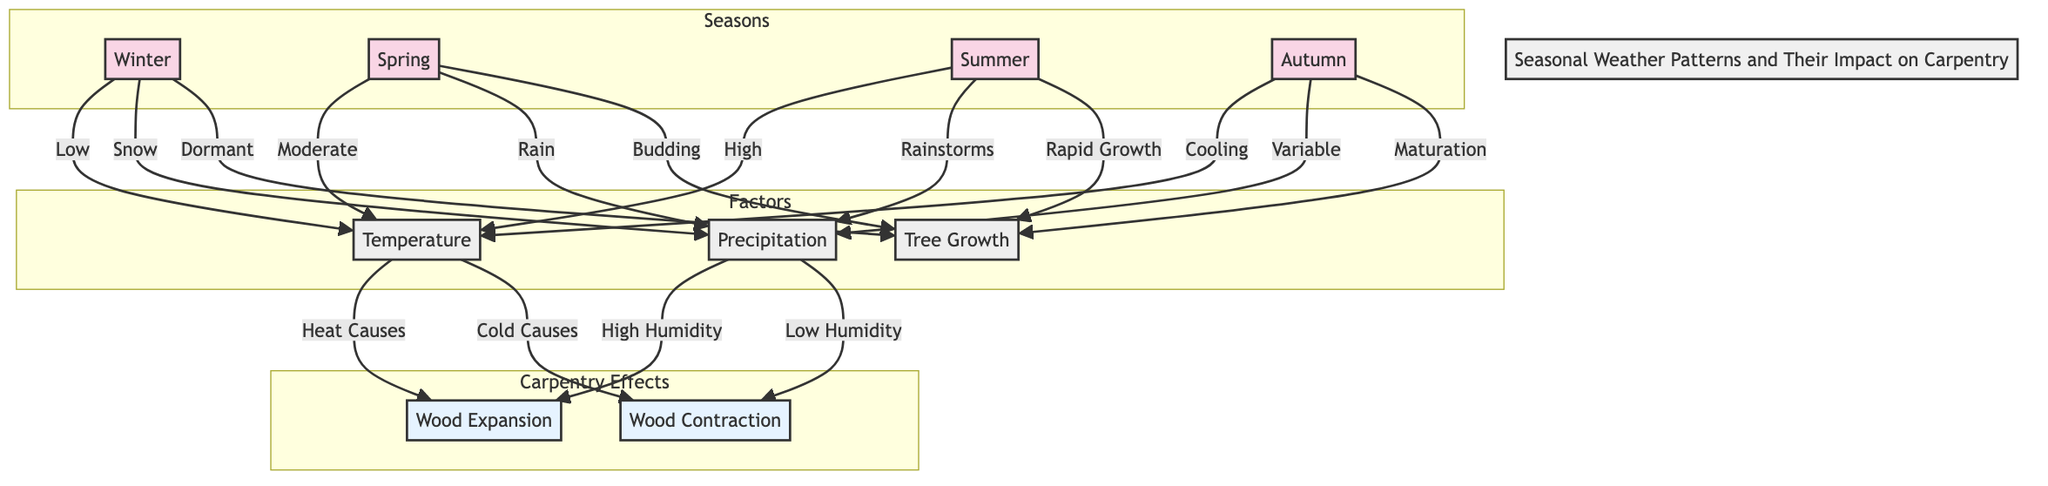What season is associated with low temperatures? The diagram shows that the winter season is linked to low temperatures, as indicated by the directed arrow relationship from Winter to Temperature with the label "Low."
Answer: Winter Which season is connected to rapid tree growth? The diagram specifies that rapid tree growth occurs during the summer season, indicated by the directed arrow from Summer to Tree Growth with the label "Rapid Growth."
Answer: Summer How many seasons are represented in the diagram? The diagram categorizes four distinct seasons: Winter, Spring, Summer, and Autumn. Thus, the count of seasons represented is four.
Answer: Four What effect does high humidity have on wood? According to the diagram, high humidity, represented by the precipitation node, causes wood to expand, as indicated by the directed arrow from Precipitation to Wood Expansion with the label "High Humidity."
Answer: Wood Expansion What is the relationship between temperature and wood contraction? The diagram illustrates that cold temperatures lead to wood contraction, as shown by the directed arrow from Temperature to Wood Contraction with the label "Cold Causes."
Answer: Wood Contraction Which season leads to variable precipitation? In the diagram, the autumn season is linked to variable precipitation, evidenced by the arrow from Autumn to Precipitation marked "Variable."
Answer: Autumn What season is characterized by tree dormancy? The diagram notes that winter is the season where trees are dormant, indicated by the relationship from Winter to Tree Growth labeled "Dormant."
Answer: Winter What is the relationship between temperature and wood expansion? The diagram indicates that heat causes wood expansion, represented by the connection from Temperature to Wood Expansion marked "Heat Causes."
Answer: Heat Causes In the summer, what type of weather phenomenon is associated with precipitation? The diagram specifies that during the summer, rainstorms are associated with precipitation, highlighted by the directed arrow from Summer to Precipitation labeled "Rainstorms."
Answer: Rainstorms 